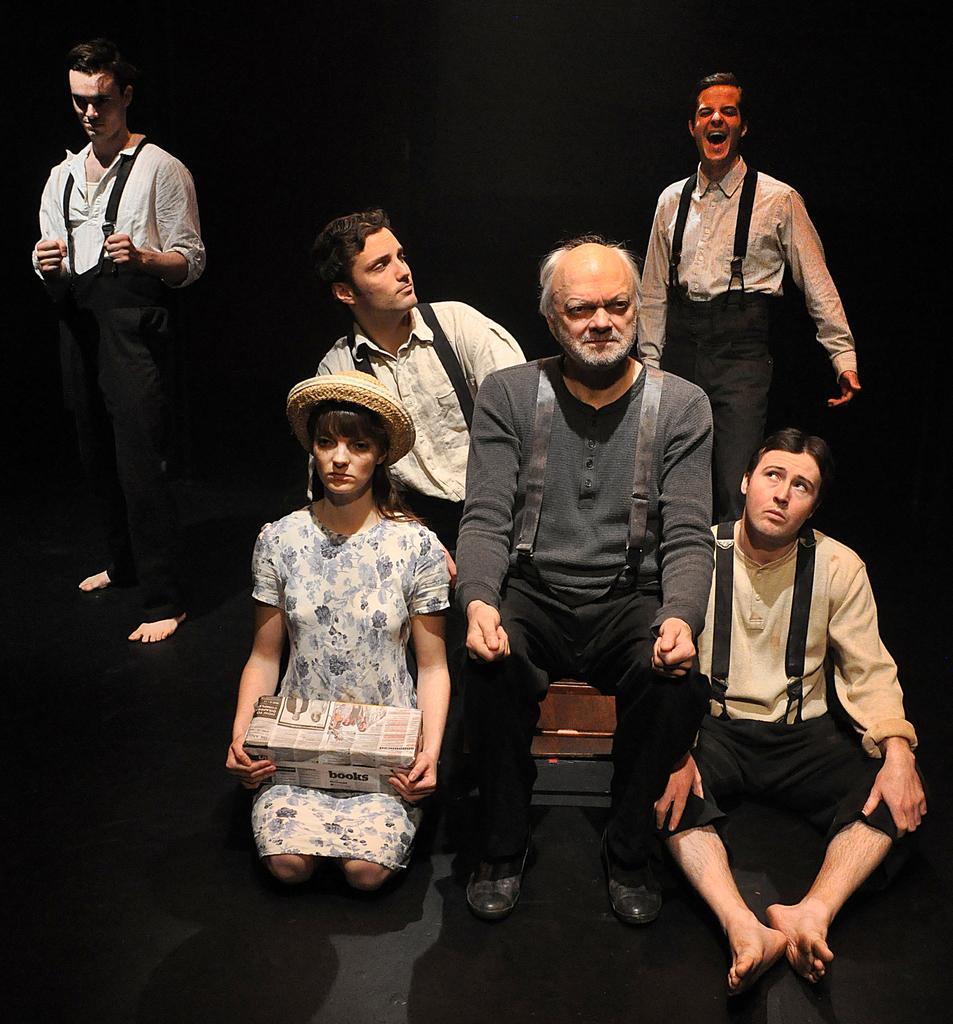Please provide a concise description of this image. In this picture we can see a woman wearing a hat and holding a box in her hand. There is a person sitting on an object. We can see a man sitting on the ground. There are a few people visible at the back. We can see the dark view in the background. 